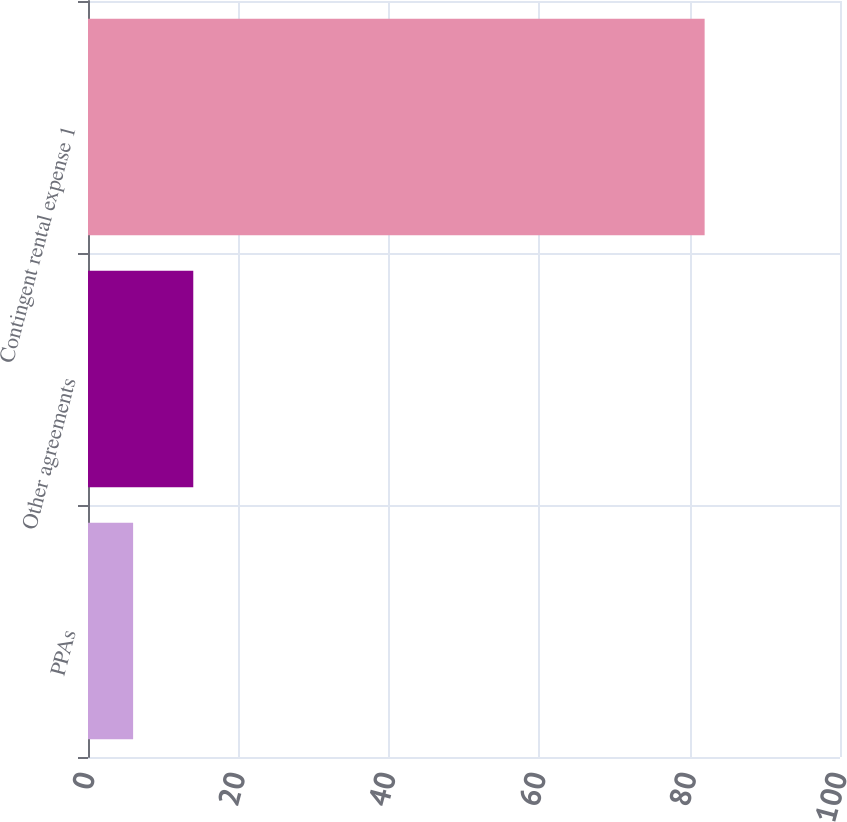<chart> <loc_0><loc_0><loc_500><loc_500><bar_chart><fcel>PPAs<fcel>Other agreements<fcel>Contingent rental expense 1<nl><fcel>6<fcel>14<fcel>82<nl></chart> 